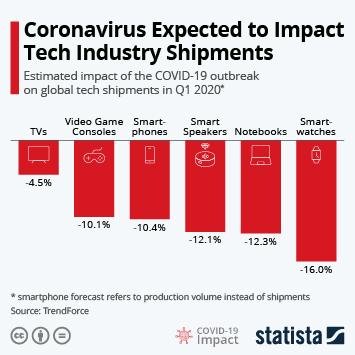Outline some significant characteristics in this image. The shipment of smartwatches is more impacted by the COVID-19 pandemic compared to TVs and smartphones. The shipment of nearly equal impact between notebooks and smart speakers is significant. The COVID-19 pandemic has had a significant impact on many industries, but the shipment of televisions has been least affected. There are 6 products shown in the bar chart. Smart speakers are impacted more in shipments than smart phones. 